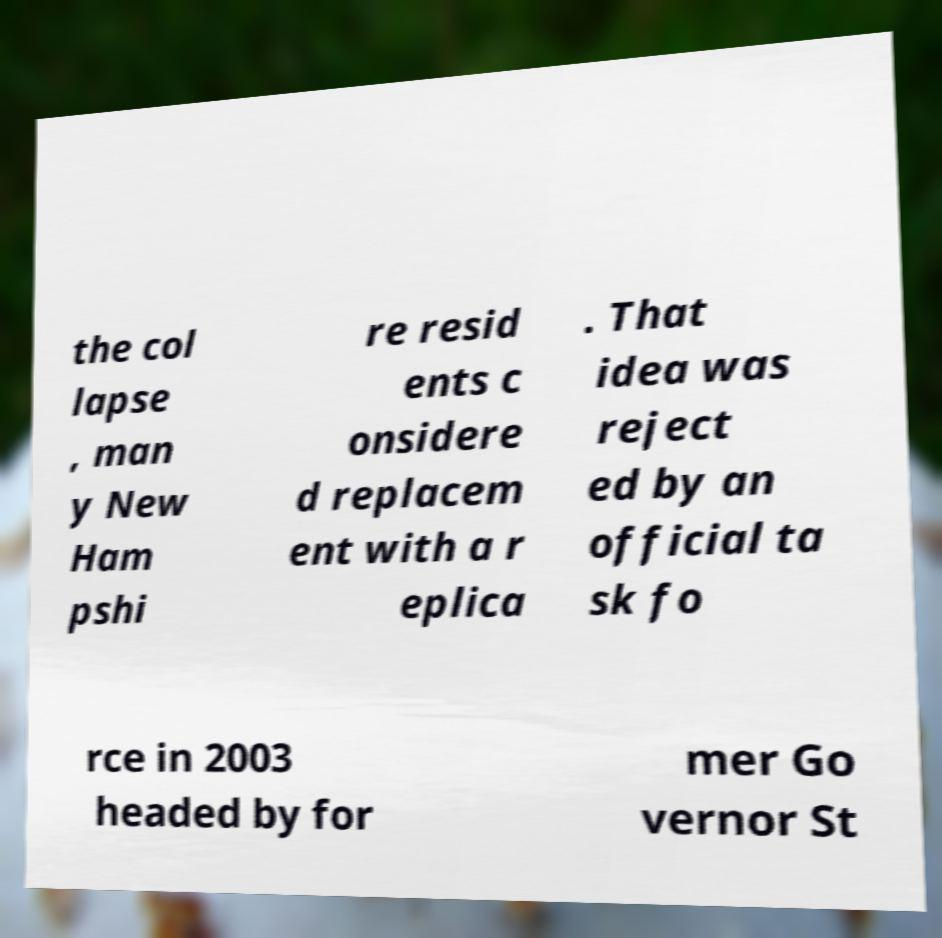I need the written content from this picture converted into text. Can you do that? the col lapse , man y New Ham pshi re resid ents c onsidere d replacem ent with a r eplica . That idea was reject ed by an official ta sk fo rce in 2003 headed by for mer Go vernor St 